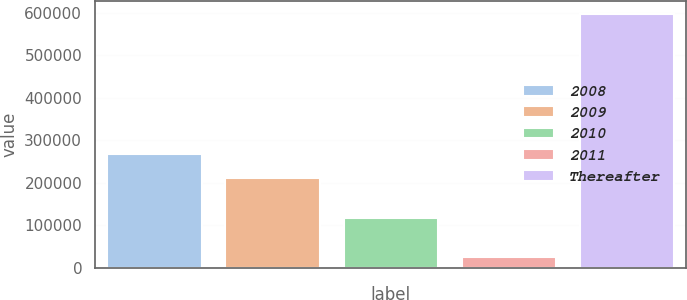<chart> <loc_0><loc_0><loc_500><loc_500><bar_chart><fcel>2008<fcel>2009<fcel>2010<fcel>2011<fcel>Thereafter<nl><fcel>268848<fcel>211653<fcel>117315<fcel>25530<fcel>597483<nl></chart> 